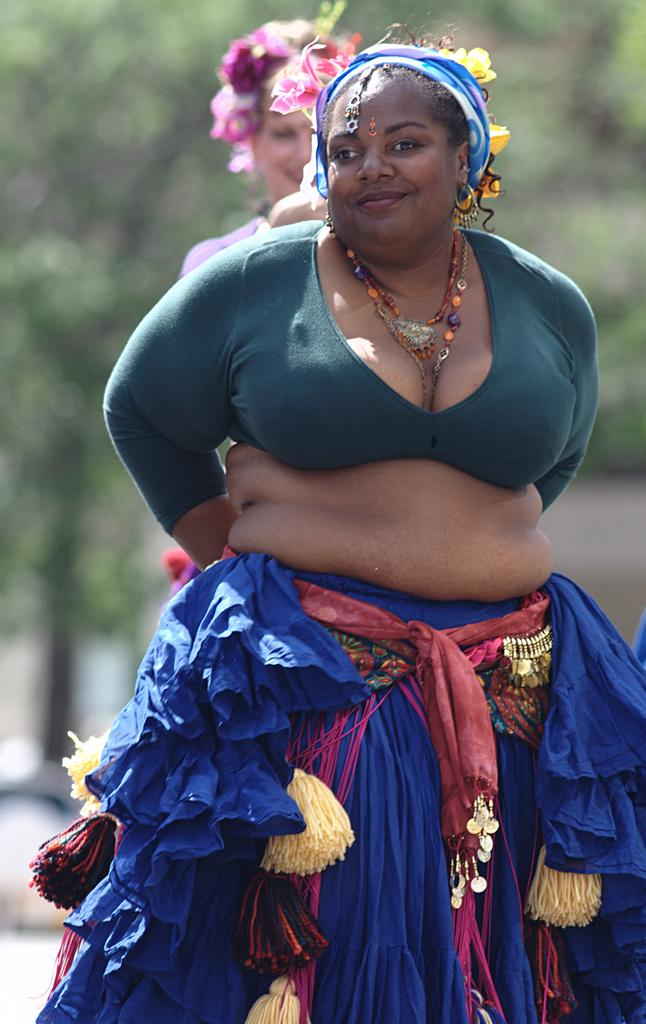How many people are in the image? There are two women in the image. What is the facial expression of the women? The women are smiling. What type of plants can be seen in the image? There are flowers and trees in the image. Can you describe the background of the image? The background of the image is blurry. What type of dress is the actor wearing in the image? There is no actor present in the image, and therefore no dress can be observed. What message of peace is being conveyed in the image? The image does not convey a specific message of peace; it simply shows two women smiling and surrounded by plants. 